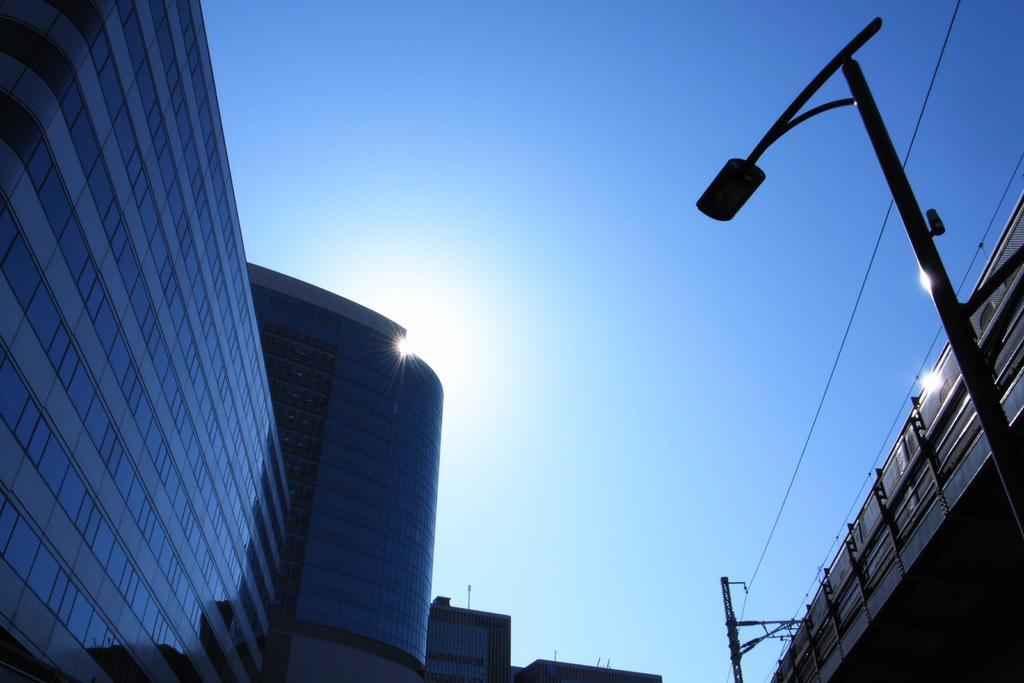In one or two sentences, can you explain what this image depicts? In this picture I can see the buildings in front and on the right side of this picture I can see a thing and I see 2 poles and wires near to it. In the background I can see the sky and the sun. 